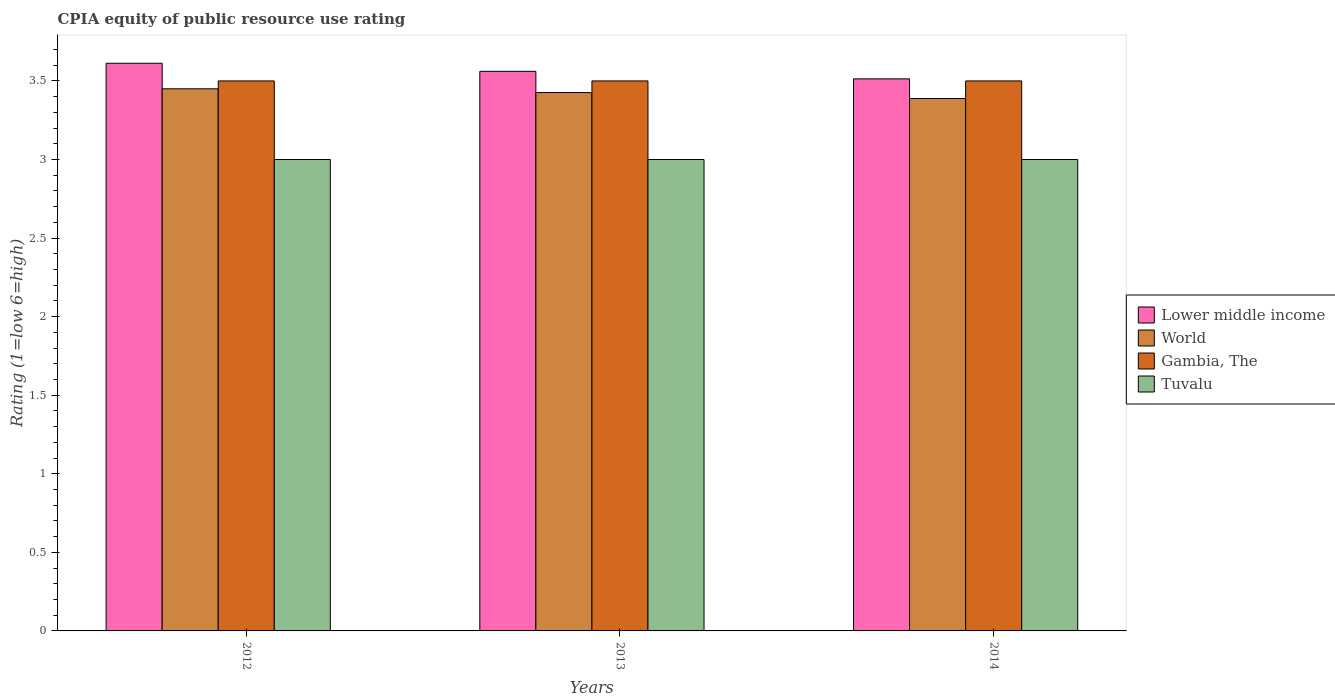Are the number of bars on each tick of the X-axis equal?
Your answer should be very brief. Yes. How many bars are there on the 1st tick from the left?
Give a very brief answer. 4. How many bars are there on the 2nd tick from the right?
Provide a succinct answer. 4. What is the label of the 2nd group of bars from the left?
Offer a terse response. 2013. What is the CPIA rating in Lower middle income in 2014?
Ensure brevity in your answer.  3.51. Across all years, what is the maximum CPIA rating in Lower middle income?
Provide a succinct answer. 3.61. Across all years, what is the minimum CPIA rating in World?
Make the answer very short. 3.39. In which year was the CPIA rating in Tuvalu maximum?
Your answer should be compact. 2012. What is the total CPIA rating in Gambia, The in the graph?
Provide a short and direct response. 10.5. What is the difference between the CPIA rating in Gambia, The in 2012 and that in 2014?
Keep it short and to the point. 0. What is the difference between the CPIA rating in Gambia, The in 2012 and the CPIA rating in Lower middle income in 2013?
Give a very brief answer. -0.06. What is the average CPIA rating in World per year?
Make the answer very short. 3.42. In the year 2014, what is the difference between the CPIA rating in World and CPIA rating in Lower middle income?
Your answer should be compact. -0.12. In how many years, is the CPIA rating in Lower middle income greater than 3.1?
Your answer should be very brief. 3. Is the CPIA rating in Tuvalu in 2012 less than that in 2013?
Ensure brevity in your answer.  No. Is the difference between the CPIA rating in World in 2012 and 2013 greater than the difference between the CPIA rating in Lower middle income in 2012 and 2013?
Your answer should be compact. No. What is the difference between the highest and the second highest CPIA rating in Tuvalu?
Ensure brevity in your answer.  0. Is the sum of the CPIA rating in Gambia, The in 2012 and 2013 greater than the maximum CPIA rating in Tuvalu across all years?
Give a very brief answer. Yes. Is it the case that in every year, the sum of the CPIA rating in Tuvalu and CPIA rating in Gambia, The is greater than the sum of CPIA rating in World and CPIA rating in Lower middle income?
Your response must be concise. No. What does the 2nd bar from the left in 2014 represents?
Offer a very short reply. World. Is it the case that in every year, the sum of the CPIA rating in World and CPIA rating in Lower middle income is greater than the CPIA rating in Gambia, The?
Give a very brief answer. Yes. How many bars are there?
Give a very brief answer. 12. Are all the bars in the graph horizontal?
Provide a short and direct response. No. How many years are there in the graph?
Provide a short and direct response. 3. What is the difference between two consecutive major ticks on the Y-axis?
Provide a short and direct response. 0.5. Are the values on the major ticks of Y-axis written in scientific E-notation?
Ensure brevity in your answer.  No. Does the graph contain grids?
Your response must be concise. No. How many legend labels are there?
Offer a very short reply. 4. What is the title of the graph?
Give a very brief answer. CPIA equity of public resource use rating. Does "Senegal" appear as one of the legend labels in the graph?
Give a very brief answer. No. What is the label or title of the Y-axis?
Your answer should be compact. Rating (1=low 6=high). What is the Rating (1=low 6=high) in Lower middle income in 2012?
Your answer should be compact. 3.61. What is the Rating (1=low 6=high) of World in 2012?
Ensure brevity in your answer.  3.45. What is the Rating (1=low 6=high) in Tuvalu in 2012?
Keep it short and to the point. 3. What is the Rating (1=low 6=high) of Lower middle income in 2013?
Offer a very short reply. 3.56. What is the Rating (1=low 6=high) of World in 2013?
Your answer should be very brief. 3.43. What is the Rating (1=low 6=high) of Gambia, The in 2013?
Ensure brevity in your answer.  3.5. What is the Rating (1=low 6=high) of Lower middle income in 2014?
Make the answer very short. 3.51. What is the Rating (1=low 6=high) in World in 2014?
Your answer should be compact. 3.39. What is the Rating (1=low 6=high) in Gambia, The in 2014?
Provide a succinct answer. 3.5. What is the Rating (1=low 6=high) of Tuvalu in 2014?
Your response must be concise. 3. Across all years, what is the maximum Rating (1=low 6=high) of Lower middle income?
Provide a succinct answer. 3.61. Across all years, what is the maximum Rating (1=low 6=high) of World?
Provide a short and direct response. 3.45. Across all years, what is the maximum Rating (1=low 6=high) of Gambia, The?
Ensure brevity in your answer.  3.5. Across all years, what is the maximum Rating (1=low 6=high) of Tuvalu?
Keep it short and to the point. 3. Across all years, what is the minimum Rating (1=low 6=high) of Lower middle income?
Your answer should be compact. 3.51. Across all years, what is the minimum Rating (1=low 6=high) of World?
Give a very brief answer. 3.39. Across all years, what is the minimum Rating (1=low 6=high) of Gambia, The?
Ensure brevity in your answer.  3.5. Across all years, what is the minimum Rating (1=low 6=high) of Tuvalu?
Keep it short and to the point. 3. What is the total Rating (1=low 6=high) in Lower middle income in the graph?
Your response must be concise. 10.69. What is the total Rating (1=low 6=high) of World in the graph?
Your answer should be compact. 10.26. What is the total Rating (1=low 6=high) of Gambia, The in the graph?
Provide a short and direct response. 10.5. What is the difference between the Rating (1=low 6=high) in Lower middle income in 2012 and that in 2013?
Make the answer very short. 0.05. What is the difference between the Rating (1=low 6=high) of World in 2012 and that in 2013?
Ensure brevity in your answer.  0.02. What is the difference between the Rating (1=low 6=high) of Tuvalu in 2012 and that in 2013?
Make the answer very short. 0. What is the difference between the Rating (1=low 6=high) of Lower middle income in 2012 and that in 2014?
Provide a succinct answer. 0.1. What is the difference between the Rating (1=low 6=high) of World in 2012 and that in 2014?
Make the answer very short. 0.06. What is the difference between the Rating (1=low 6=high) in Gambia, The in 2012 and that in 2014?
Offer a terse response. 0. What is the difference between the Rating (1=low 6=high) of Lower middle income in 2013 and that in 2014?
Give a very brief answer. 0.05. What is the difference between the Rating (1=low 6=high) of World in 2013 and that in 2014?
Offer a very short reply. 0.04. What is the difference between the Rating (1=low 6=high) of Gambia, The in 2013 and that in 2014?
Your response must be concise. 0. What is the difference between the Rating (1=low 6=high) of Lower middle income in 2012 and the Rating (1=low 6=high) of World in 2013?
Provide a short and direct response. 0.19. What is the difference between the Rating (1=low 6=high) of Lower middle income in 2012 and the Rating (1=low 6=high) of Gambia, The in 2013?
Your answer should be very brief. 0.11. What is the difference between the Rating (1=low 6=high) in Lower middle income in 2012 and the Rating (1=low 6=high) in Tuvalu in 2013?
Provide a short and direct response. 0.61. What is the difference between the Rating (1=low 6=high) in World in 2012 and the Rating (1=low 6=high) in Gambia, The in 2013?
Your answer should be compact. -0.05. What is the difference between the Rating (1=low 6=high) in World in 2012 and the Rating (1=low 6=high) in Tuvalu in 2013?
Your response must be concise. 0.45. What is the difference between the Rating (1=low 6=high) in Gambia, The in 2012 and the Rating (1=low 6=high) in Tuvalu in 2013?
Provide a short and direct response. 0.5. What is the difference between the Rating (1=low 6=high) of Lower middle income in 2012 and the Rating (1=low 6=high) of World in 2014?
Offer a very short reply. 0.22. What is the difference between the Rating (1=low 6=high) in Lower middle income in 2012 and the Rating (1=low 6=high) in Gambia, The in 2014?
Your answer should be compact. 0.11. What is the difference between the Rating (1=low 6=high) in Lower middle income in 2012 and the Rating (1=low 6=high) in Tuvalu in 2014?
Your answer should be very brief. 0.61. What is the difference between the Rating (1=low 6=high) of World in 2012 and the Rating (1=low 6=high) of Tuvalu in 2014?
Offer a terse response. 0.45. What is the difference between the Rating (1=low 6=high) of Gambia, The in 2012 and the Rating (1=low 6=high) of Tuvalu in 2014?
Offer a very short reply. 0.5. What is the difference between the Rating (1=low 6=high) in Lower middle income in 2013 and the Rating (1=low 6=high) in World in 2014?
Make the answer very short. 0.17. What is the difference between the Rating (1=low 6=high) in Lower middle income in 2013 and the Rating (1=low 6=high) in Gambia, The in 2014?
Offer a very short reply. 0.06. What is the difference between the Rating (1=low 6=high) of Lower middle income in 2013 and the Rating (1=low 6=high) of Tuvalu in 2014?
Offer a terse response. 0.56. What is the difference between the Rating (1=low 6=high) in World in 2013 and the Rating (1=low 6=high) in Gambia, The in 2014?
Provide a succinct answer. -0.07. What is the difference between the Rating (1=low 6=high) of World in 2013 and the Rating (1=low 6=high) of Tuvalu in 2014?
Your answer should be very brief. 0.43. What is the difference between the Rating (1=low 6=high) of Gambia, The in 2013 and the Rating (1=low 6=high) of Tuvalu in 2014?
Ensure brevity in your answer.  0.5. What is the average Rating (1=low 6=high) in Lower middle income per year?
Ensure brevity in your answer.  3.56. What is the average Rating (1=low 6=high) in World per year?
Provide a short and direct response. 3.42. What is the average Rating (1=low 6=high) in Tuvalu per year?
Offer a very short reply. 3. In the year 2012, what is the difference between the Rating (1=low 6=high) in Lower middle income and Rating (1=low 6=high) in World?
Provide a succinct answer. 0.16. In the year 2012, what is the difference between the Rating (1=low 6=high) of Lower middle income and Rating (1=low 6=high) of Gambia, The?
Your answer should be compact. 0.11. In the year 2012, what is the difference between the Rating (1=low 6=high) in Lower middle income and Rating (1=low 6=high) in Tuvalu?
Your answer should be compact. 0.61. In the year 2012, what is the difference between the Rating (1=low 6=high) in World and Rating (1=low 6=high) in Tuvalu?
Your answer should be very brief. 0.45. In the year 2012, what is the difference between the Rating (1=low 6=high) of Gambia, The and Rating (1=low 6=high) of Tuvalu?
Keep it short and to the point. 0.5. In the year 2013, what is the difference between the Rating (1=low 6=high) of Lower middle income and Rating (1=low 6=high) of World?
Your answer should be compact. 0.14. In the year 2013, what is the difference between the Rating (1=low 6=high) of Lower middle income and Rating (1=low 6=high) of Gambia, The?
Keep it short and to the point. 0.06. In the year 2013, what is the difference between the Rating (1=low 6=high) of Lower middle income and Rating (1=low 6=high) of Tuvalu?
Give a very brief answer. 0.56. In the year 2013, what is the difference between the Rating (1=low 6=high) in World and Rating (1=low 6=high) in Gambia, The?
Give a very brief answer. -0.07. In the year 2013, what is the difference between the Rating (1=low 6=high) of World and Rating (1=low 6=high) of Tuvalu?
Give a very brief answer. 0.43. In the year 2013, what is the difference between the Rating (1=low 6=high) of Gambia, The and Rating (1=low 6=high) of Tuvalu?
Offer a very short reply. 0.5. In the year 2014, what is the difference between the Rating (1=low 6=high) of Lower middle income and Rating (1=low 6=high) of Gambia, The?
Ensure brevity in your answer.  0.01. In the year 2014, what is the difference between the Rating (1=low 6=high) of Lower middle income and Rating (1=low 6=high) of Tuvalu?
Provide a succinct answer. 0.51. In the year 2014, what is the difference between the Rating (1=low 6=high) of World and Rating (1=low 6=high) of Gambia, The?
Make the answer very short. -0.11. In the year 2014, what is the difference between the Rating (1=low 6=high) of World and Rating (1=low 6=high) of Tuvalu?
Your answer should be compact. 0.39. In the year 2014, what is the difference between the Rating (1=low 6=high) in Gambia, The and Rating (1=low 6=high) in Tuvalu?
Offer a terse response. 0.5. What is the ratio of the Rating (1=low 6=high) of Lower middle income in 2012 to that in 2013?
Offer a terse response. 1.01. What is the ratio of the Rating (1=low 6=high) of World in 2012 to that in 2013?
Provide a short and direct response. 1.01. What is the ratio of the Rating (1=low 6=high) in Gambia, The in 2012 to that in 2013?
Offer a very short reply. 1. What is the ratio of the Rating (1=low 6=high) of Lower middle income in 2012 to that in 2014?
Give a very brief answer. 1.03. What is the ratio of the Rating (1=low 6=high) of World in 2012 to that in 2014?
Ensure brevity in your answer.  1.02. What is the ratio of the Rating (1=low 6=high) in Lower middle income in 2013 to that in 2014?
Your answer should be very brief. 1.01. What is the ratio of the Rating (1=low 6=high) in World in 2013 to that in 2014?
Provide a short and direct response. 1.01. What is the difference between the highest and the second highest Rating (1=low 6=high) in Lower middle income?
Make the answer very short. 0.05. What is the difference between the highest and the second highest Rating (1=low 6=high) in World?
Offer a very short reply. 0.02. What is the difference between the highest and the second highest Rating (1=low 6=high) of Gambia, The?
Provide a short and direct response. 0. What is the difference between the highest and the lowest Rating (1=low 6=high) in Lower middle income?
Offer a terse response. 0.1. What is the difference between the highest and the lowest Rating (1=low 6=high) of World?
Ensure brevity in your answer.  0.06. What is the difference between the highest and the lowest Rating (1=low 6=high) in Gambia, The?
Ensure brevity in your answer.  0. 